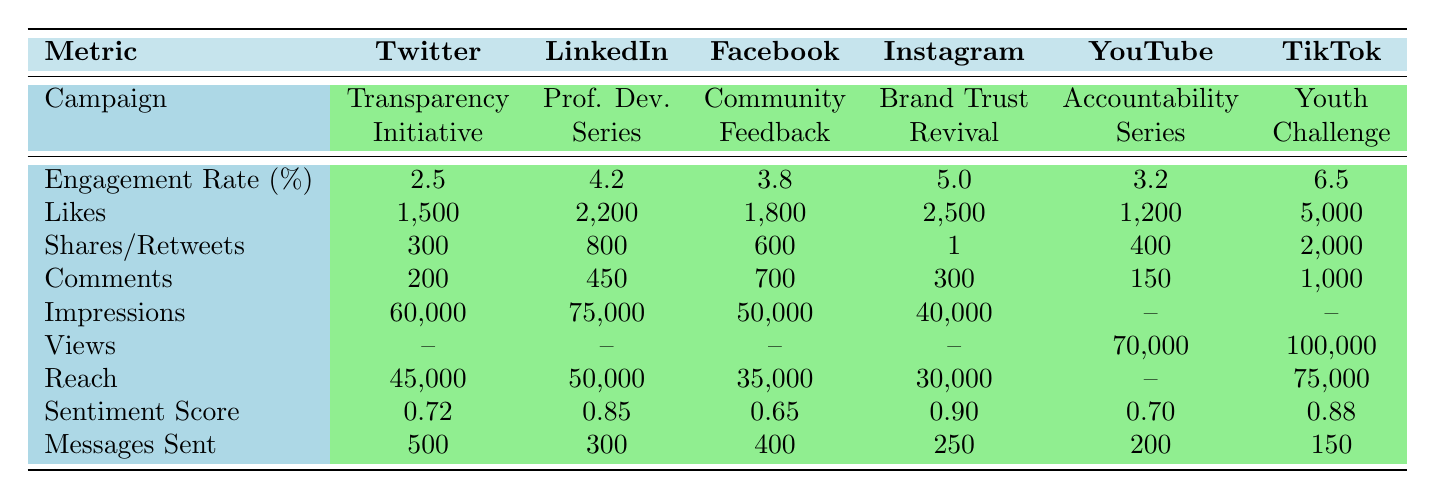What is the engagement rate of the TikTok Youth Engagement Challenge? The engagement rate for the TikTok Youth Engagement Challenge is explicitly listed in the table under the "Engagement Rate" row for TikTok, which shows a value of 6.5%.
Answer: 6.5% Which campaign had the highest number of likes? By comparing the "Likes" column for each campaign, TikTok Youth Engagement Challenge has the highest number of likes at 5,000, followed by Instagram Brand Trust Revival with 2,500.
Answer: TikTok Youth Engagement Challenge How many comments were received for the Facebook Community Feedback Sessions? The number of comments for the Facebook campaign can be directly found in the "Comments" row, which states there were 700 comments.
Answer: 700 What is the average engagement rate of all campaigns? To find the average engagement rate, sum the engagement rates of all campaigns (2.5 + 4.2 + 3.8 + 5.0 + 3.2 + 6.5 = 25.2) and divide by the number of campaigns (6), resulting in an average engagement rate of about 4.2%.
Answer: 4.2% Did the YouTube Corporate Accountability Series receive more likes or comments? The YouTube campaign received 1,200 likes and 150 comments. Comparing these two numbers, 1,200 (likes) is greater than 150 (comments).
Answer: More likes Which platform had the highest reach and what was the value? By looking at the "Reach" column, TikTok has the highest reach at 75,000.
Answer: TikTok, 75,000 True or False: The sentiment score for the Instagram Brand Trust Revival is lower than 0.85. The sentiment score for Instagram is 0.90, which is higher than 0.85. Therefore, the statement is false.
Answer: False Which campaign had the lowest reach and what was the value? By examining the "Reach" column, Instagram has the lowest reach at 30,000, lower than Facebook's 35,000.
Answer: Instagram, 30,000 If we sum the number of shares and likes for LinkedIn, what is the total? To find this, we add the likes (2,200) and shares (800) for LinkedIn together (2,200 + 800 = 3,000).
Answer: 3,000 Which sentiment score is the lowest across all campaigns? Looking at the "Sentiment Score" row, Facebook Community Feedback Sessions has the lowest value at 0.65 compared to others.
Answer: 0.65 